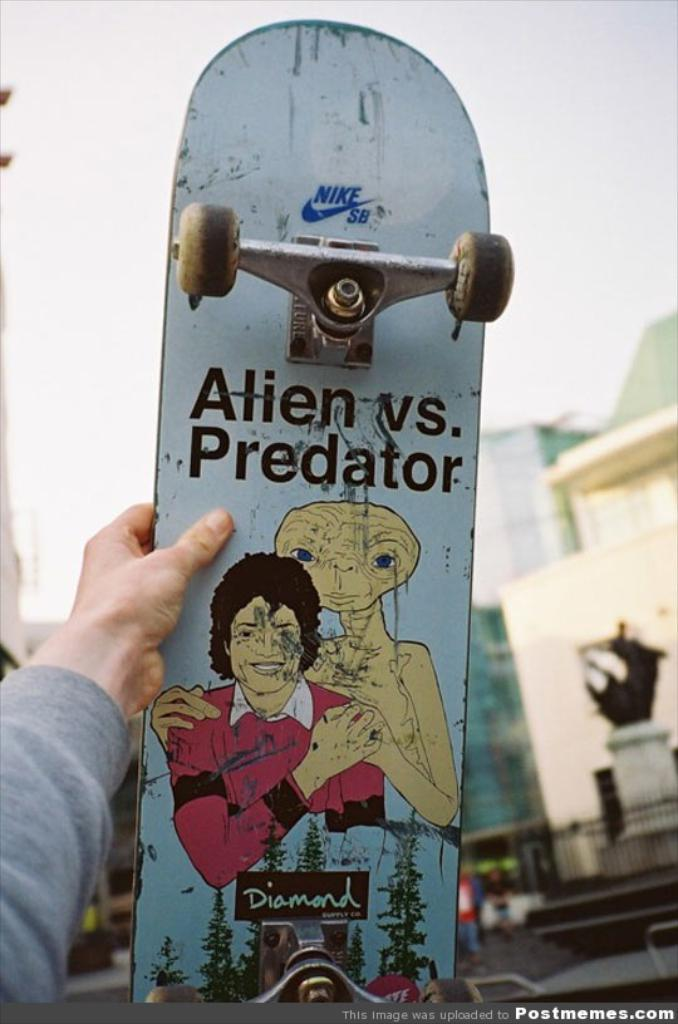What is the main subject of the image? There is a person in the image. What is the person holding in the image? The person is holding a skateboard. Can you describe the skateboard? The skateboard has words and paintings on it. What can be seen in the background of the image? There are buildings and the sky visible in the background of the image. Are there any additional features of the image? Yes, there are watermarks on the image. What type of desk is visible in the image? There is no desk present in the image. How many squares are on the skateboard in the image? The skateboard in the image does not have any squares; it has words and paintings. 